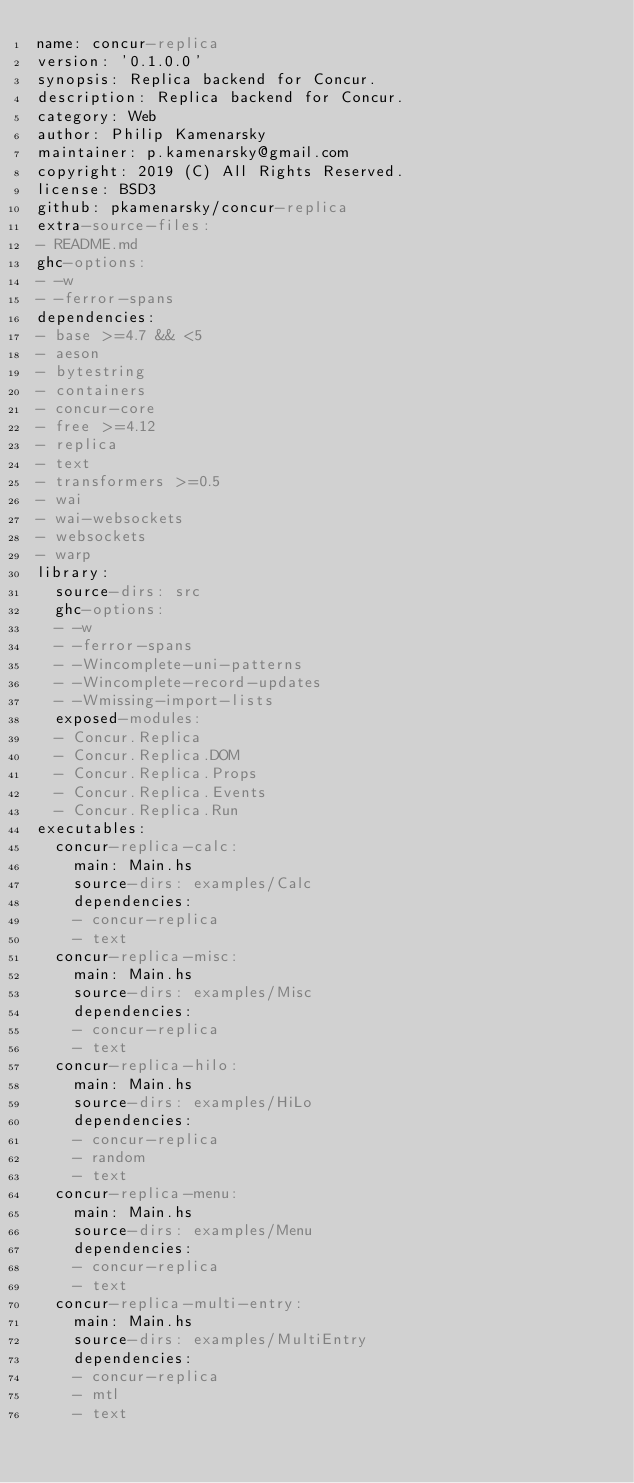<code> <loc_0><loc_0><loc_500><loc_500><_YAML_>name: concur-replica
version: '0.1.0.0'
synopsis: Replica backend for Concur.
description: Replica backend for Concur.
category: Web
author: Philip Kamenarsky
maintainer: p.kamenarsky@gmail.com
copyright: 2019 (C) All Rights Reserved.
license: BSD3
github: pkamenarsky/concur-replica
extra-source-files:
- README.md
ghc-options:
- -w
- -ferror-spans
dependencies:
- base >=4.7 && <5
- aeson
- bytestring
- containers
- concur-core
- free >=4.12
- replica
- text
- transformers >=0.5
- wai
- wai-websockets
- websockets
- warp
library:
  source-dirs: src
  ghc-options:
  - -w
  - -ferror-spans
  - -Wincomplete-uni-patterns
  - -Wincomplete-record-updates
  - -Wmissing-import-lists
  exposed-modules:
  - Concur.Replica
  - Concur.Replica.DOM
  - Concur.Replica.Props
  - Concur.Replica.Events
  - Concur.Replica.Run
executables:
  concur-replica-calc:
    main: Main.hs
    source-dirs: examples/Calc
    dependencies:
    - concur-replica
    - text
  concur-replica-misc:
    main: Main.hs
    source-dirs: examples/Misc
    dependencies:
    - concur-replica
    - text
  concur-replica-hilo:
    main: Main.hs
    source-dirs: examples/HiLo
    dependencies:
    - concur-replica
    - random
    - text
  concur-replica-menu:
    main: Main.hs
    source-dirs: examples/Menu
    dependencies:
    - concur-replica
    - text
  concur-replica-multi-entry:
    main: Main.hs
    source-dirs: examples/MultiEntry
    dependencies:
    - concur-replica
    - mtl
    - text
</code> 